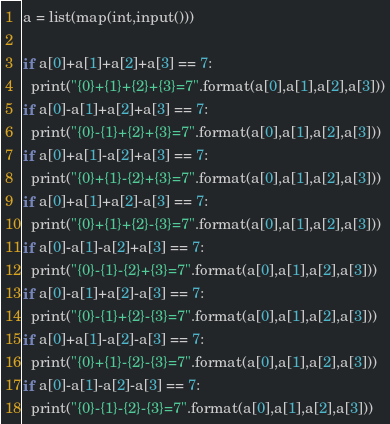Convert code to text. <code><loc_0><loc_0><loc_500><loc_500><_Python_>a = list(map(int,input()))

if a[0]+a[1]+a[2]+a[3] == 7:
  print("{0}+{1}+{2}+{3}=7".format(a[0],a[1],a[2],a[3]))
if a[0]-a[1]+a[2]+a[3] == 7:
  print("{0}-{1}+{2}+{3}=7".format(a[0],a[1],a[2],a[3]))
if a[0]+a[1]-a[2]+a[3] == 7:
  print("{0}+{1}-{2}+{3}=7".format(a[0],a[1],a[2],a[3]))
if a[0]+a[1]+a[2]-a[3] == 7:
  print("{0}+{1}+{2}-{3}=7".format(a[0],a[1],a[2],a[3]))
if a[0]-a[1]-a[2]+a[3] == 7:
  print("{0}-{1}-{2}+{3}=7".format(a[0],a[1],a[2],a[3]))
if a[0]-a[1]+a[2]-a[3] == 7:
  print("{0}-{1}+{2}-{3}=7".format(a[0],a[1],a[2],a[3]))
if a[0]+a[1]-a[2]-a[3] == 7:
  print("{0}+{1}-{2}-{3}=7".format(a[0],a[1],a[2],a[3]))
if a[0]-a[1]-a[2]-a[3] == 7:
  print("{0}-{1}-{2}-{3}=7".format(a[0],a[1],a[2],a[3]))
</code> 